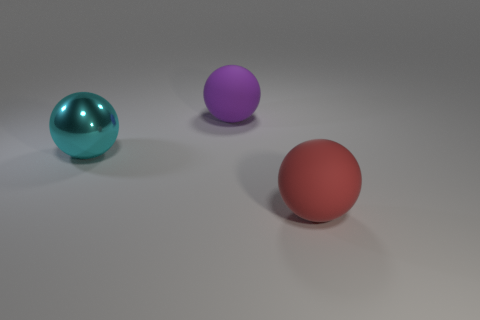Is there a big purple object to the left of the big rubber ball in front of the big purple sphere?
Your answer should be compact. Yes. What number of things are balls behind the cyan sphere or rubber objects?
Your response must be concise. 2. How many cyan things are there?
Your answer should be compact. 1. The thing that is made of the same material as the big red ball is what shape?
Offer a very short reply. Sphere. What number of things are cyan shiny spheres that are behind the red rubber sphere or objects left of the red sphere?
Offer a terse response. 2. Is the number of big rubber balls less than the number of big yellow rubber blocks?
Keep it short and to the point. No. What number of objects are either large red rubber objects or matte things?
Your answer should be compact. 2. Do the large red matte object and the purple rubber object have the same shape?
Your response must be concise. Yes. Are there any other things that have the same material as the cyan thing?
Offer a very short reply. No. There is a matte ball that is right of the large purple rubber ball; does it have the same size as the ball that is behind the big metal sphere?
Your answer should be very brief. Yes. 